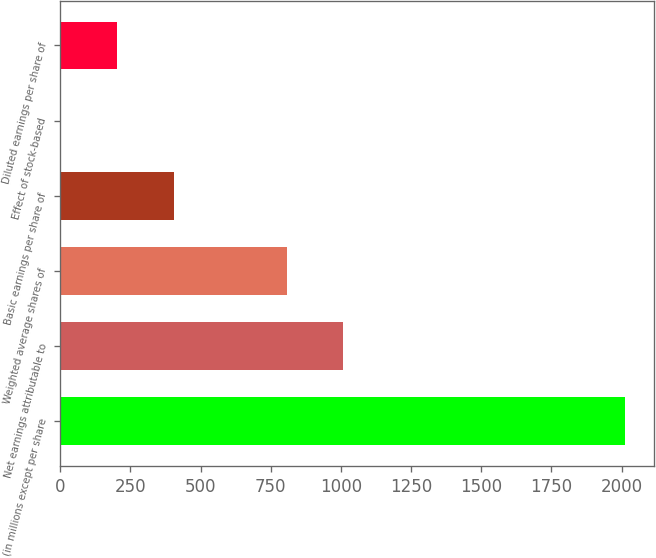Convert chart. <chart><loc_0><loc_0><loc_500><loc_500><bar_chart><fcel>(in millions except per share<fcel>Net earnings attributable to<fcel>Weighted average shares of<fcel>Basic earnings per share of<fcel>Effect of stock-based<fcel>Diluted earnings per share of<nl><fcel>2014<fcel>1007.87<fcel>806.65<fcel>404.21<fcel>1.77<fcel>202.99<nl></chart> 